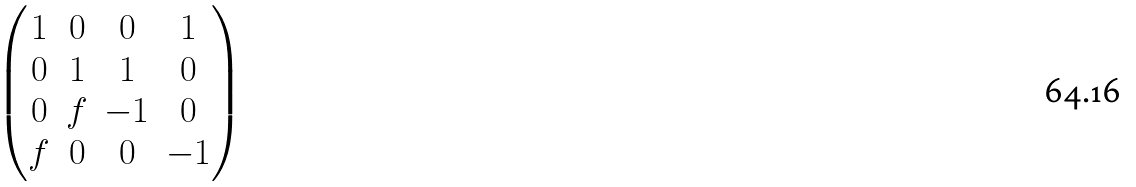<formula> <loc_0><loc_0><loc_500><loc_500>\begin{pmatrix} 1 & 0 & 0 & 1 \\ 0 & 1 & 1 & 0 \\ 0 & f & - 1 & 0 \\ f & 0 & 0 & - 1 \end{pmatrix}</formula> 